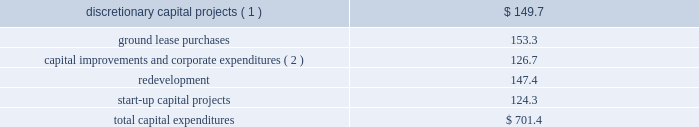As of december 31 , 2016 , we had total outstanding indebtedness of $ 18.7 billion , with a current portion of $ 238.8 million .
During the year ended december 31 , 2016 , we generated sufficient cash flow from operations to fund our capital expenditures and debt service obligations , as well as our required distributions .
We believe the cash generated by operating activities during the year ending december 31 , 2017 will be sufficient to fund our required distributions , capital expenditures , debt service obligations ( interest and principal repayments ) and signed acquisitions .
As of december 31 , 2016 , we had $ 423.0 million of cash and cash equivalents held by our foreign subsidiaries , of which $ 183.9 million was held by our joint ventures .
While certain subsidiaries may pay us interest or principal on intercompany debt , it has not been our practice to repatriate earnings from our foreign subsidiaries primarily due to our ongoing expansion efforts and related capital needs .
However , in the event that we do repatriate any funds , we may be required to accrue and pay taxes .
Cash flows from operating activities for the year ended december 31 , 2016 , cash provided by operating activities increased $ 520.6 million as compared to the year ended december 31 , 2015 .
The primary factors that impacted cash provided by operating activities as compared to the year ended december 31 , 2015 , include : 2022 an increase in our operating profit of $ 490.8 million ; 2022 an increase of approximately $ 67.1 million in cash paid for interest ; and 2022 a decrease of approximately $ 60.8 million in cash paid for taxes .
For the year ended december 31 , 2015 , cash provided by operating activities increased $ 48.5 million as compared to the year ended december 31 , 2014 .
The primary factors that impacted cash provided by operating activities as compared to the year ended december 31 , 2014 , include : 2022 an increase in our operating profit of $ 433.3 million ; 2022 an increase of approximately $ 87.8 million in cash paid for taxes , driven primarily by the mipt one-time cash tax charge of $ 93.0 million ; 2022 a decrease in capital contributions , tenant settlements and other prepayments of approximately $ 99.0 million ; 2022 an increase of approximately $ 29.9 million in cash paid for interest ; 2022 a decrease of approximately $ 34.9 million in termination and decommissioning fees ; 2022 a decrease of approximately $ 49.0 million in tenant receipts due to timing ; and 2022 a decrease due to the non-recurrence of a 2014 value added tax refund of approximately $ 60.3 million .
Cash flows from investing activities our significant investing activities during the year ended december 31 , 2016 are highlighted below : 2022 we spent approximately $ 1.1 billion for the viom acquisition .
2022 we spent $ 701.4 million for capital expenditures , as follows ( in millions ) : .
_______________ ( 1 ) includes the construction of 1869 communications sites globally .
( 2 ) includes $ 18.9 million of capital lease payments included in repayments of notes payable , credit facilities , term loan , senior notes and capital leases in the cash flow from financing activities in our consolidated statement of cash flows .
Our significant investing transactions in 2015 included the following : 2022 we spent $ 5.059 billion for the verizon transaction .
2022 we spent $ 796.9 million for the acquisition of 5483 communications sites from tim in brazil .
2022 we spent $ 1.1 billion for the acquisition of 4716 communications sites from certain of airtel 2019s subsidiaries in nigeria. .
What portion of the total capital expenditures is related to redevelopment? 
Computations: (147.4 / 701.4)
Answer: 0.21015. As of december 31 , 2016 , we had total outstanding indebtedness of $ 18.7 billion , with a current portion of $ 238.8 million .
During the year ended december 31 , 2016 , we generated sufficient cash flow from operations to fund our capital expenditures and debt service obligations , as well as our required distributions .
We believe the cash generated by operating activities during the year ending december 31 , 2017 will be sufficient to fund our required distributions , capital expenditures , debt service obligations ( interest and principal repayments ) and signed acquisitions .
As of december 31 , 2016 , we had $ 423.0 million of cash and cash equivalents held by our foreign subsidiaries , of which $ 183.9 million was held by our joint ventures .
While certain subsidiaries may pay us interest or principal on intercompany debt , it has not been our practice to repatriate earnings from our foreign subsidiaries primarily due to our ongoing expansion efforts and related capital needs .
However , in the event that we do repatriate any funds , we may be required to accrue and pay taxes .
Cash flows from operating activities for the year ended december 31 , 2016 , cash provided by operating activities increased $ 520.6 million as compared to the year ended december 31 , 2015 .
The primary factors that impacted cash provided by operating activities as compared to the year ended december 31 , 2015 , include : 2022 an increase in our operating profit of $ 490.8 million ; 2022 an increase of approximately $ 67.1 million in cash paid for interest ; and 2022 a decrease of approximately $ 60.8 million in cash paid for taxes .
For the year ended december 31 , 2015 , cash provided by operating activities increased $ 48.5 million as compared to the year ended december 31 , 2014 .
The primary factors that impacted cash provided by operating activities as compared to the year ended december 31 , 2014 , include : 2022 an increase in our operating profit of $ 433.3 million ; 2022 an increase of approximately $ 87.8 million in cash paid for taxes , driven primarily by the mipt one-time cash tax charge of $ 93.0 million ; 2022 a decrease in capital contributions , tenant settlements and other prepayments of approximately $ 99.0 million ; 2022 an increase of approximately $ 29.9 million in cash paid for interest ; 2022 a decrease of approximately $ 34.9 million in termination and decommissioning fees ; 2022 a decrease of approximately $ 49.0 million in tenant receipts due to timing ; and 2022 a decrease due to the non-recurrence of a 2014 value added tax refund of approximately $ 60.3 million .
Cash flows from investing activities our significant investing activities during the year ended december 31 , 2016 are highlighted below : 2022 we spent approximately $ 1.1 billion for the viom acquisition .
2022 we spent $ 701.4 million for capital expenditures , as follows ( in millions ) : .
_______________ ( 1 ) includes the construction of 1869 communications sites globally .
( 2 ) includes $ 18.9 million of capital lease payments included in repayments of notes payable , credit facilities , term loan , senior notes and capital leases in the cash flow from financing activities in our consolidated statement of cash flows .
Our significant investing transactions in 2015 included the following : 2022 we spent $ 5.059 billion for the verizon transaction .
2022 we spent $ 796.9 million for the acquisition of 5483 communications sites from tim in brazil .
2022 we spent $ 1.1 billion for the acquisition of 4716 communications sites from certain of airtel 2019s subsidiaries in nigeria. .
As part of the acquisition of 5483 communications sites from tim in brazil what was the average price per site in millions? 
Computations: (796.9 / 5483)
Answer: 0.14534. 